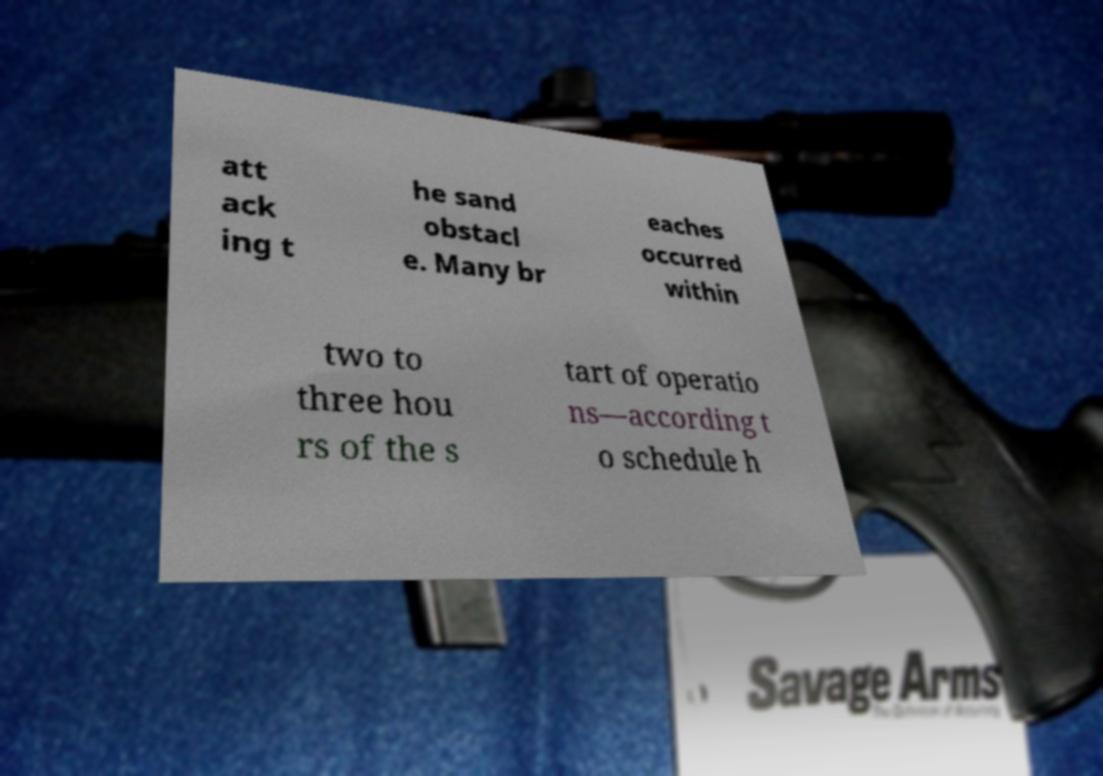Can you accurately transcribe the text from the provided image for me? att ack ing t he sand obstacl e. Many br eaches occurred within two to three hou rs of the s tart of operatio ns—according t o schedule h 